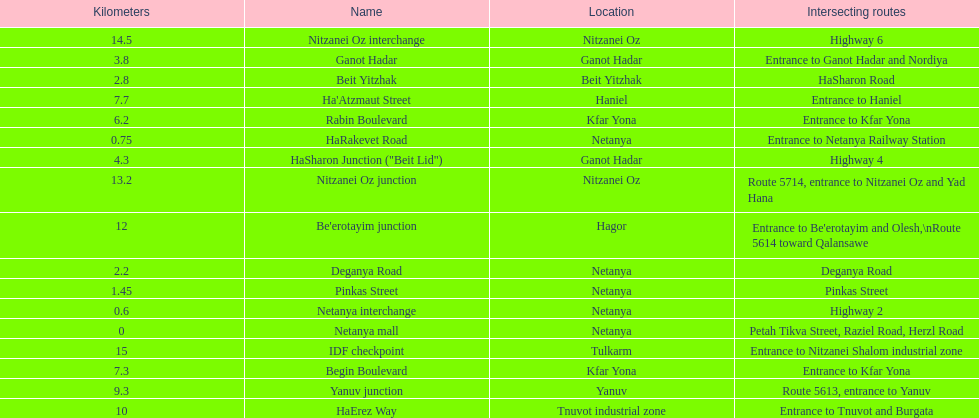Which portion has the same intersecting route as rabin boulevard? Begin Boulevard. 